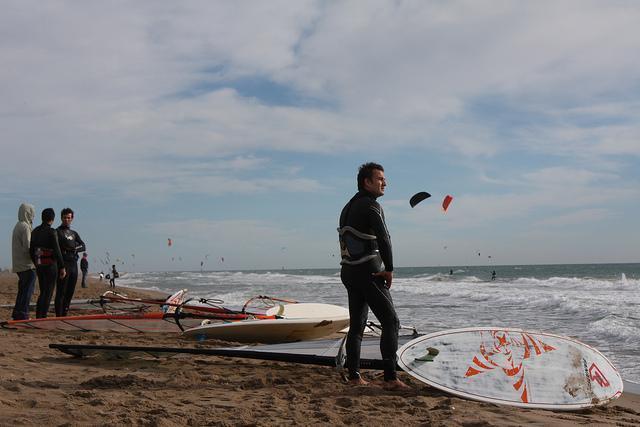How many surfboards are in the photo?
Give a very brief answer. 2. How many people are visible?
Give a very brief answer. 3. 